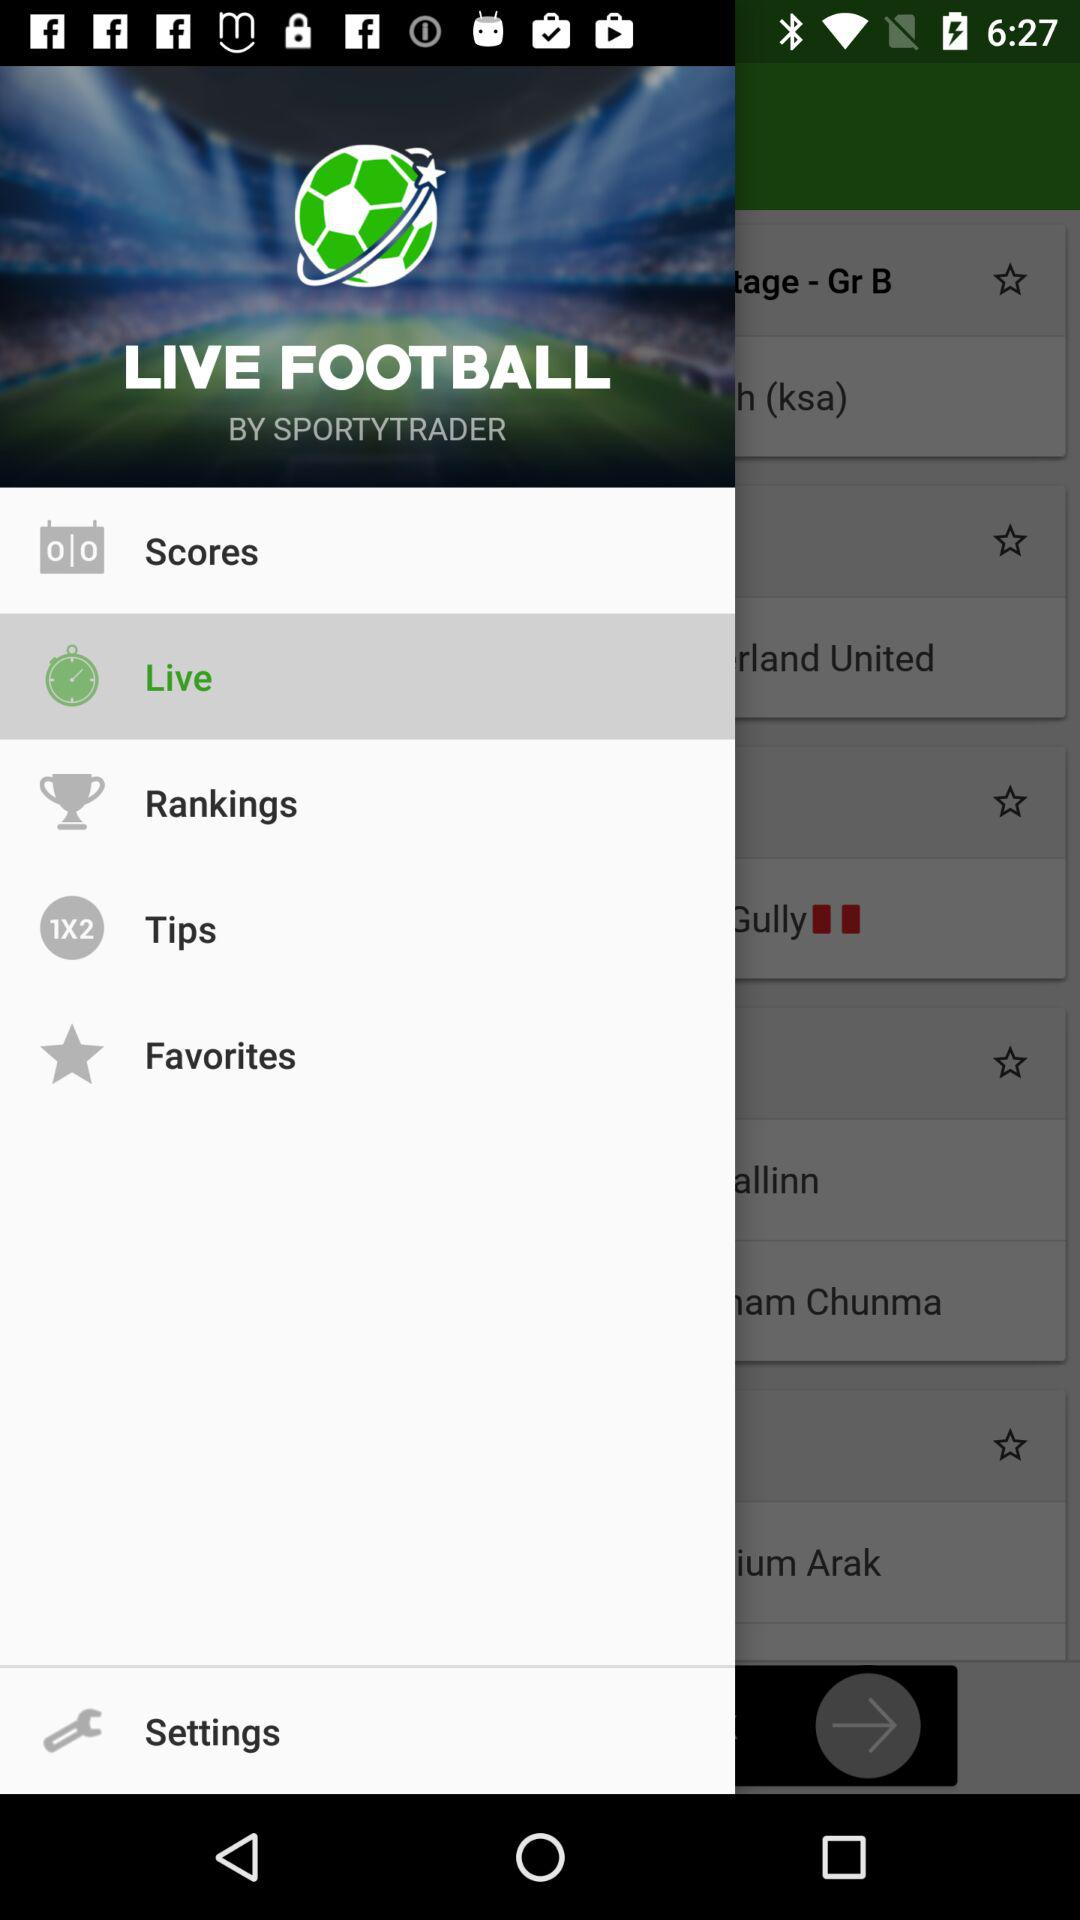What is the name of the application? The name of the application is "LIVE FOOTBALL". 